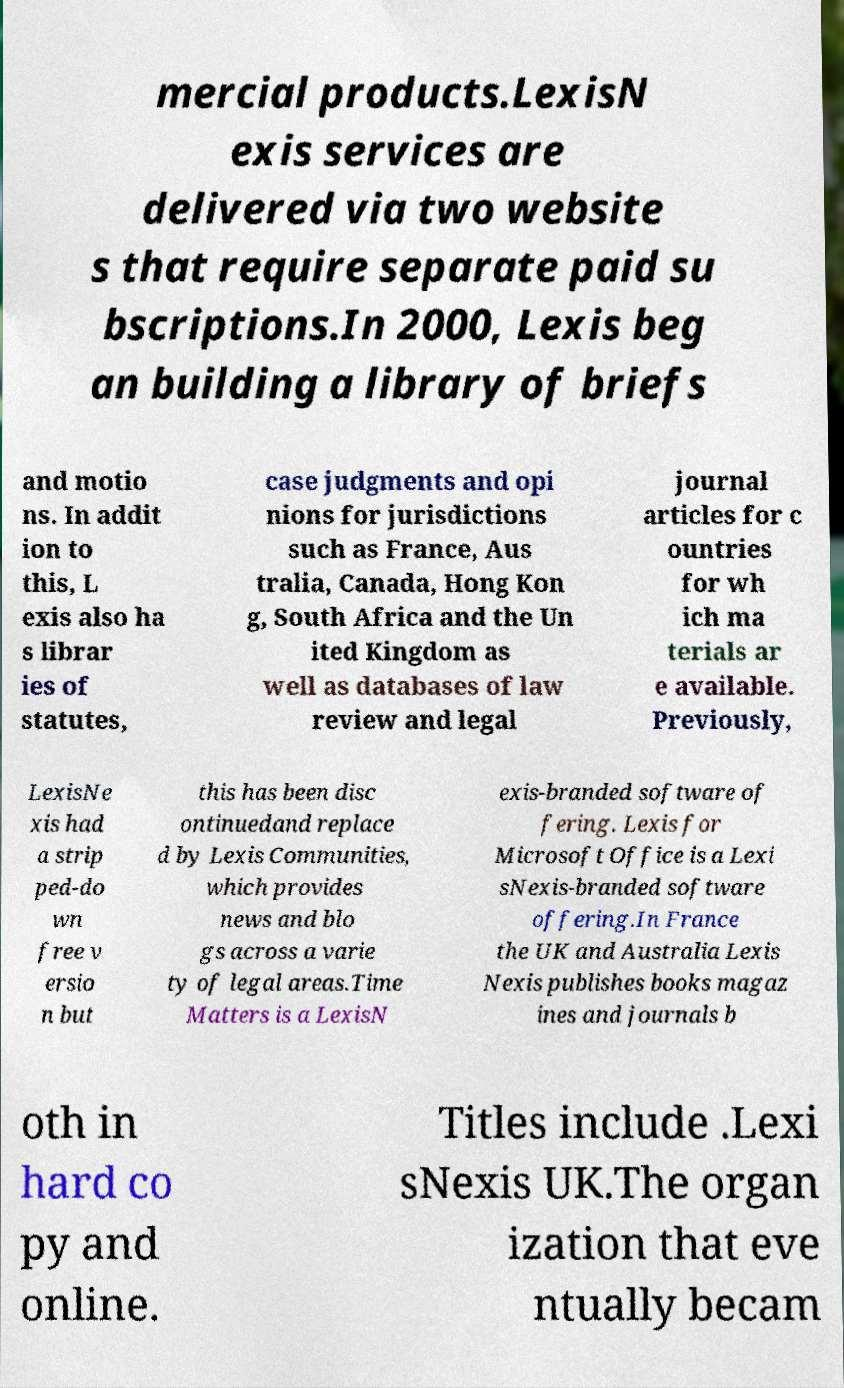Could you extract and type out the text from this image? mercial products.LexisN exis services are delivered via two website s that require separate paid su bscriptions.In 2000, Lexis beg an building a library of briefs and motio ns. In addit ion to this, L exis also ha s librar ies of statutes, case judgments and opi nions for jurisdictions such as France, Aus tralia, Canada, Hong Kon g, South Africa and the Un ited Kingdom as well as databases of law review and legal journal articles for c ountries for wh ich ma terials ar e available. Previously, LexisNe xis had a strip ped-do wn free v ersio n but this has been disc ontinuedand replace d by Lexis Communities, which provides news and blo gs across a varie ty of legal areas.Time Matters is a LexisN exis-branded software of fering. Lexis for Microsoft Office is a Lexi sNexis-branded software offering.In France the UK and Australia Lexis Nexis publishes books magaz ines and journals b oth in hard co py and online. Titles include .Lexi sNexis UK.The organ ization that eve ntually becam 